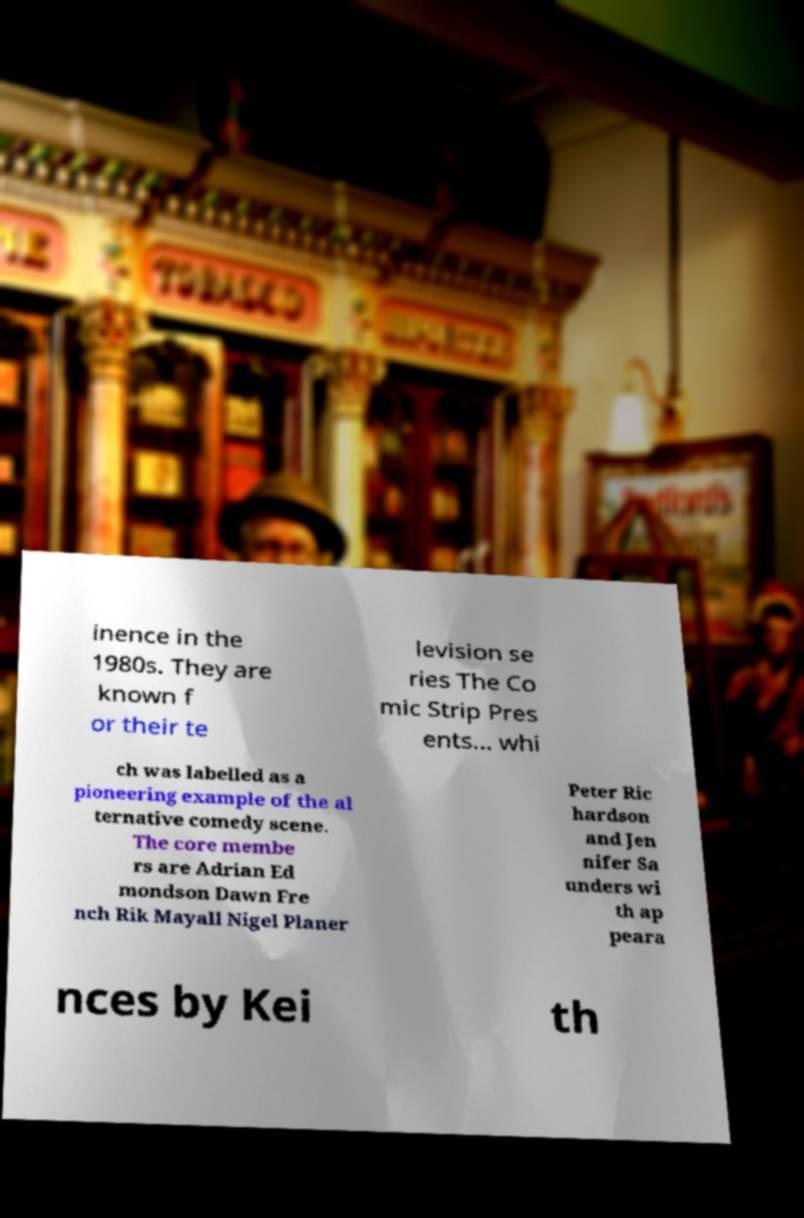Can you accurately transcribe the text from the provided image for me? inence in the 1980s. They are known f or their te levision se ries The Co mic Strip Pres ents... whi ch was labelled as a pioneering example of the al ternative comedy scene. The core membe rs are Adrian Ed mondson Dawn Fre nch Rik Mayall Nigel Planer Peter Ric hardson and Jen nifer Sa unders wi th ap peara nces by Kei th 